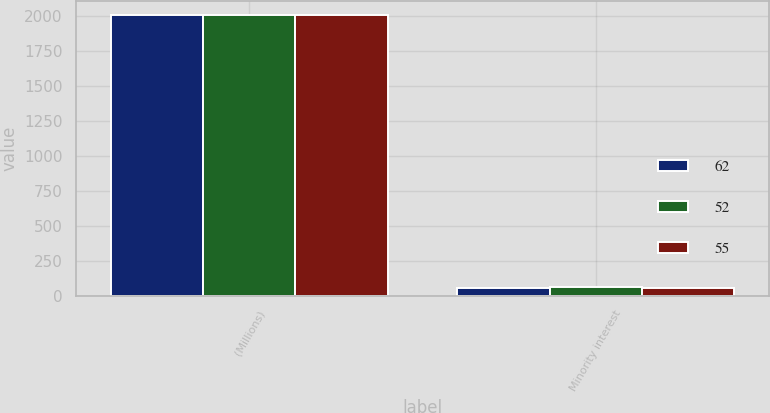Convert chart to OTSL. <chart><loc_0><loc_0><loc_500><loc_500><stacked_bar_chart><ecel><fcel>(Millions)<fcel>Minority interest<nl><fcel>62<fcel>2005<fcel>55<nl><fcel>52<fcel>2004<fcel>62<nl><fcel>55<fcel>2003<fcel>52<nl></chart> 